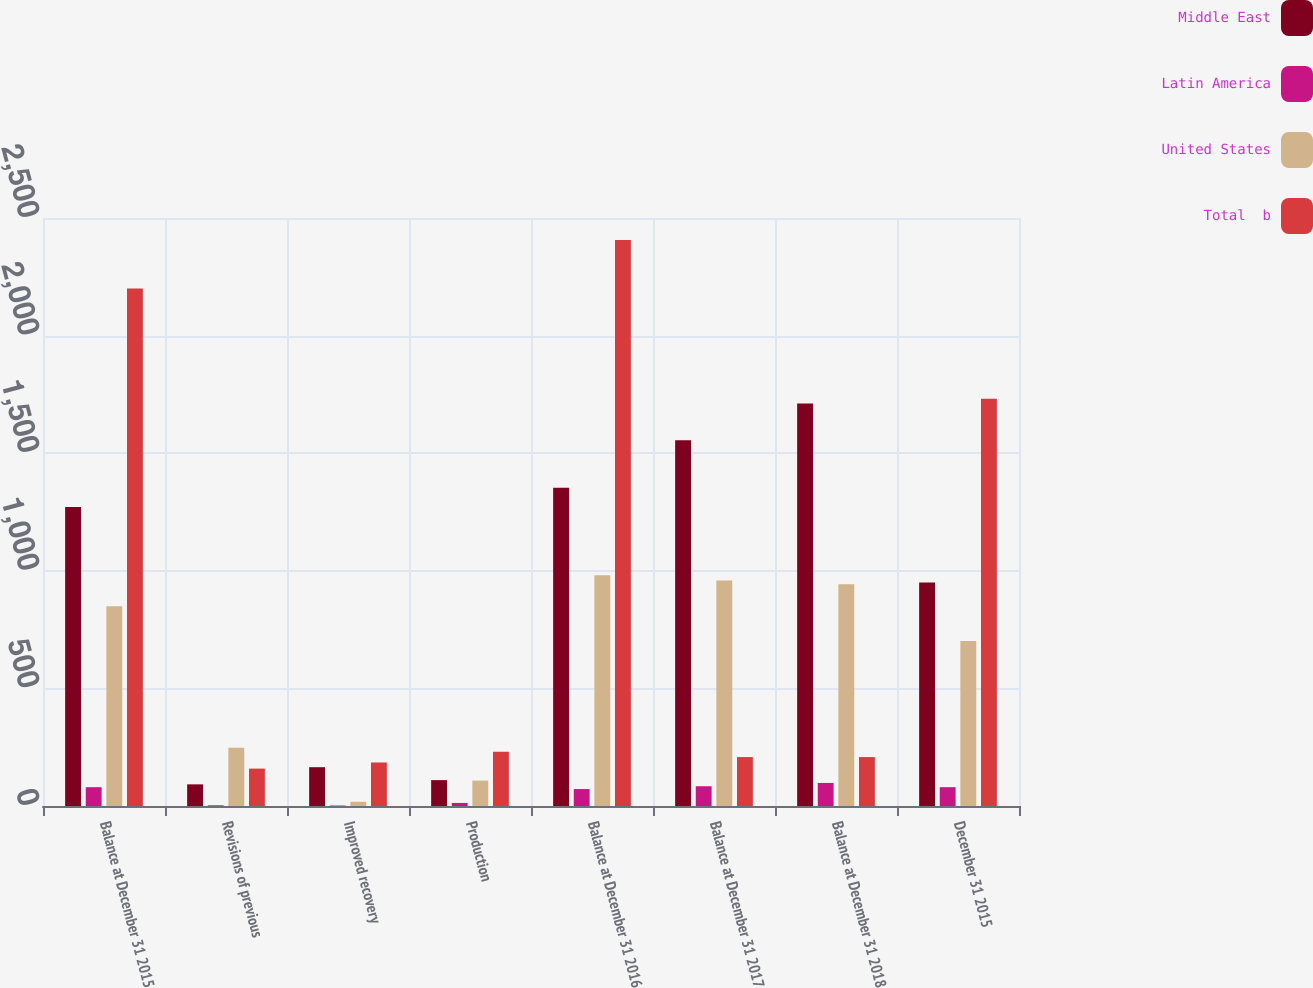Convert chart to OTSL. <chart><loc_0><loc_0><loc_500><loc_500><stacked_bar_chart><ecel><fcel>Balance at December 31 2015<fcel>Revisions of previous<fcel>Improved recovery<fcel>Production<fcel>Balance at December 31 2016<fcel>Balance at December 31 2017<fcel>Balance at December 31 2018<fcel>December 31 2015<nl><fcel>Middle East<fcel>1271<fcel>92<fcel>165<fcel>110<fcel>1353<fcel>1555<fcel>1711<fcel>950<nl><fcel>Latin America<fcel>80<fcel>3<fcel>2<fcel>13<fcel>72<fcel>84<fcel>98<fcel>80<nl><fcel>United States<fcel>849<fcel>248<fcel>18<fcel>108<fcel>981<fcel>959<fcel>943<fcel>702<nl><fcel>Total  b<fcel>2200<fcel>159<fcel>185<fcel>231<fcel>2406<fcel>208<fcel>208<fcel>1732<nl></chart> 